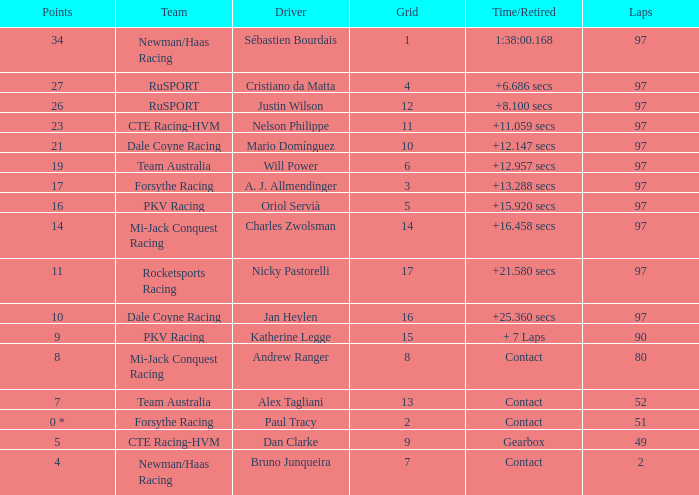What is the highest number of laps for the driver with 5 points? 49.0. 